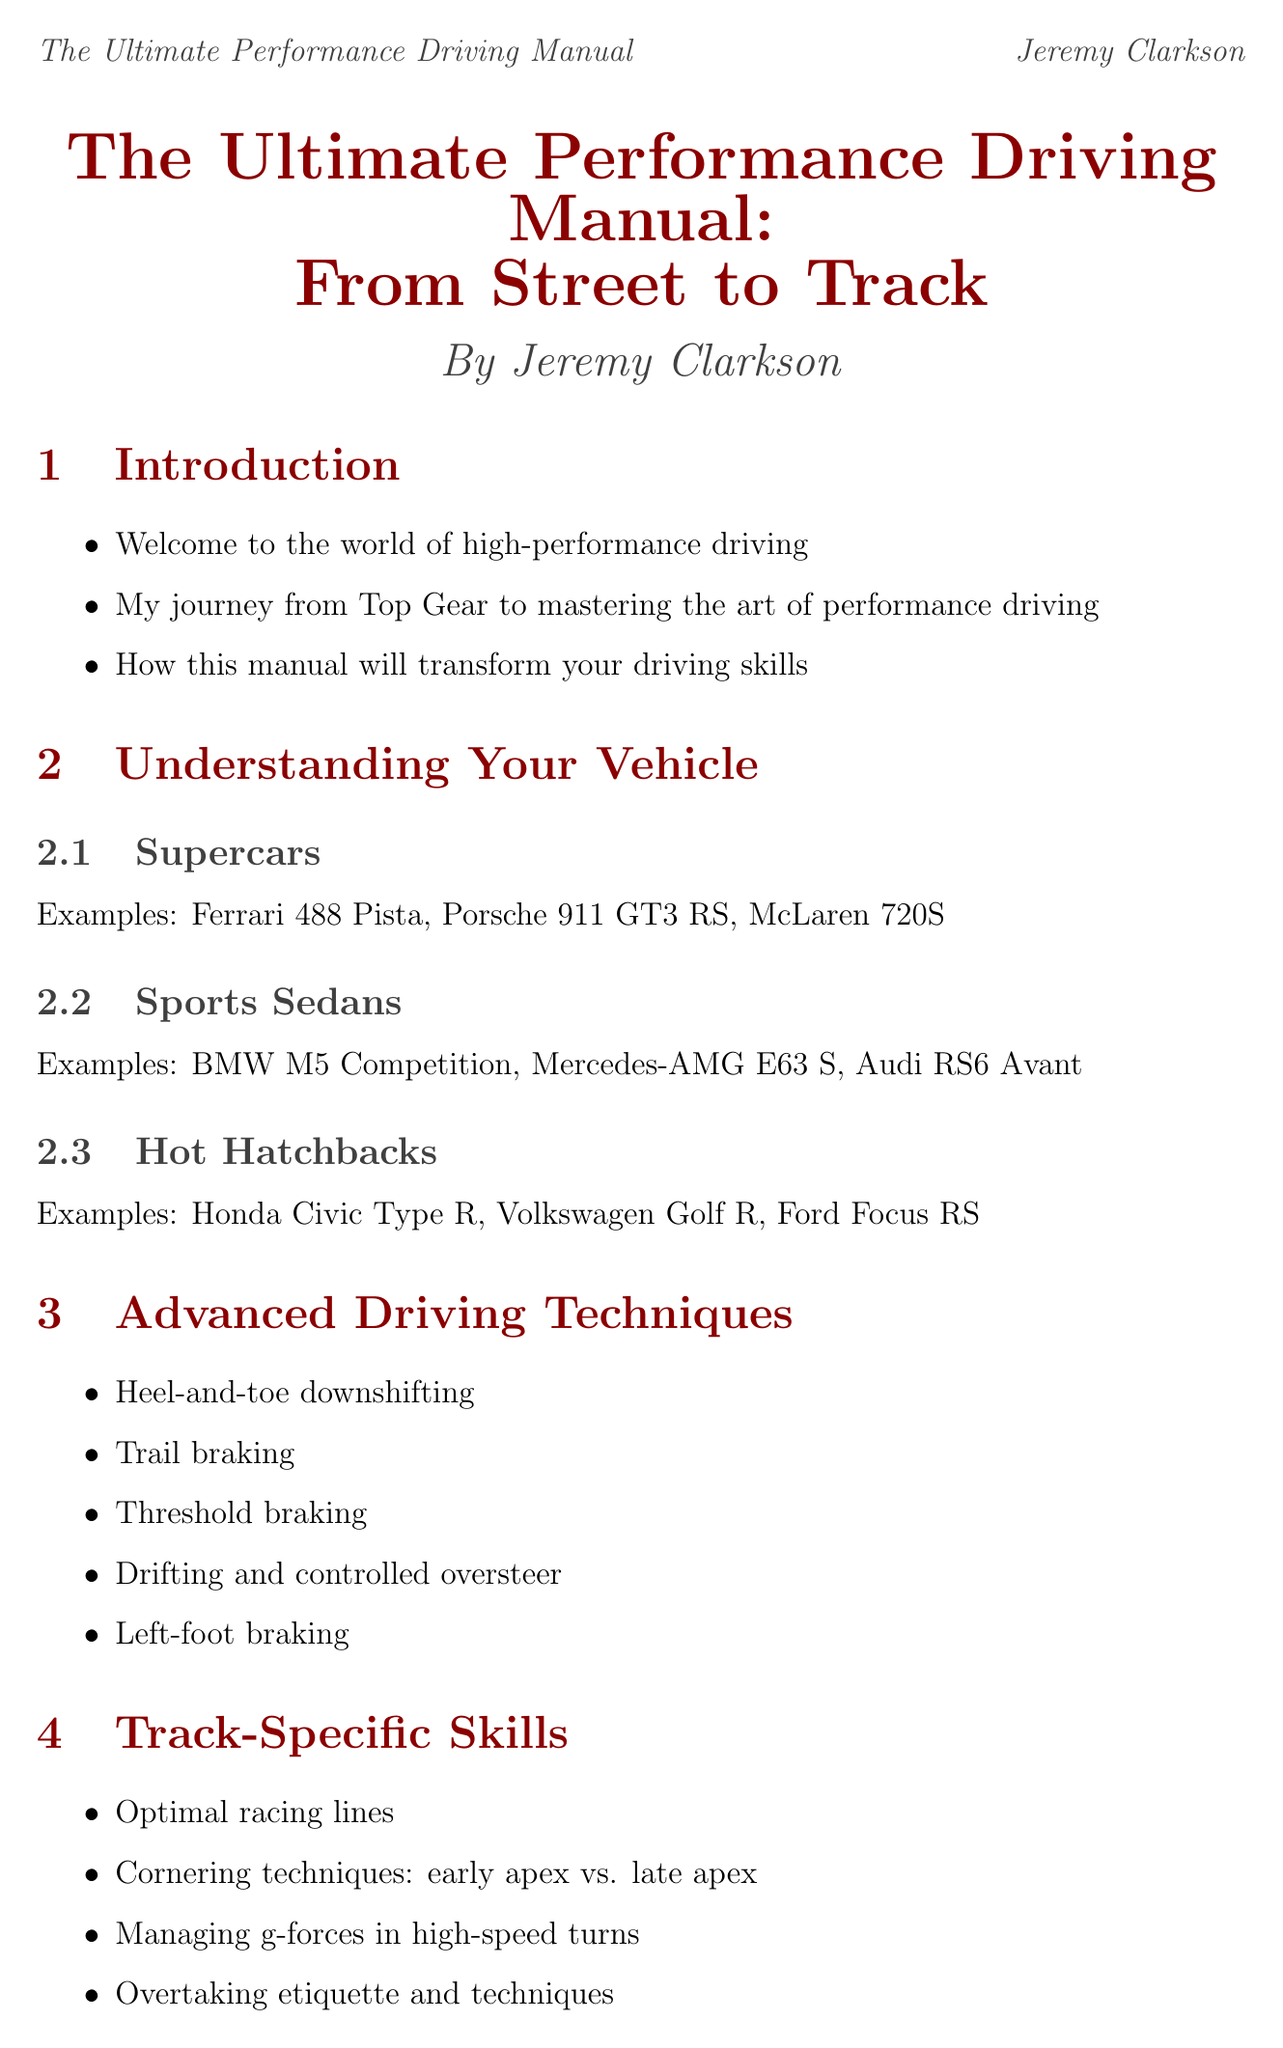What is the title of the manual? The title is mentioned prominently at the beginning of the document as the comprehensive guide for driving skills.
Answer: The Ultimate Performance Driving Manual: From Street to Track Who is the author of the manual? The author is listed next to the title, providing credibility to the document.
Answer: Jeremy Clarkson How many types of vehicles are discussed in the "Understanding Your Vehicle" section? The section outlines three main categories of vehicles, providing examples for each type.
Answer: Three What advanced technique involves changing gears while braking? This is a specific driving technique discussed in the manual for enhancing performance.
Answer: Heel-and-toe downshifting What is one notable feature of the Nürburgring Nordschleife? This is a famous racetrack mentioned in the document along with its key attributes.
Answer: Carousel What technique is recommended to manage adrenaline before driving? This mental preparation tactic is suggested for performance driving improvement.
Answer: Managing adrenaline and nerves What is one item included in the safety protocols? Safety is crucial for performance driving, and specific protocols are outlined in the manual.
Answer: Pre-drive vehicle inspection What should drivers respect during track day etiquette? This aspect of track interaction is emphasized in the etiquette section.
Answer: Other drivers and their space What is the length of Laguna Seca? The document provides specific measurements for famous racetracks and their characteristics.
Answer: 3.602 km 